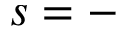<formula> <loc_0><loc_0><loc_500><loc_500>s = -</formula> 